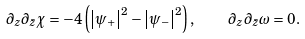Convert formula to latex. <formula><loc_0><loc_0><loc_500><loc_500>\partial _ { z } \partial _ { \bar { z } } \chi = - 4 \left ( { { \left | { { \psi } _ { + } } \right | } ^ { 2 } - { \left | { { \psi } _ { - } } \right | } ^ { 2 } } \right ) , \quad \partial _ { z } \partial _ { \bar { z } } \omega = 0 .</formula> 